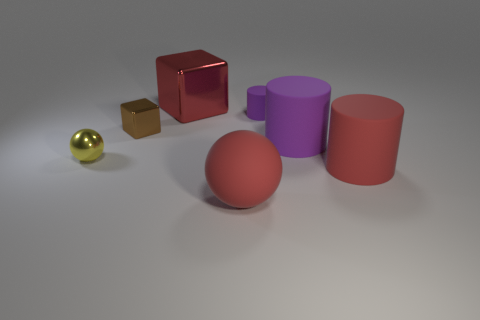Add 3 cylinders. How many objects exist? 10 Subtract all balls. How many objects are left? 5 Subtract 0 purple cubes. How many objects are left? 7 Subtract all red objects. Subtract all small green matte cubes. How many objects are left? 4 Add 1 small brown cubes. How many small brown cubes are left? 2 Add 5 metal spheres. How many metal spheres exist? 6 